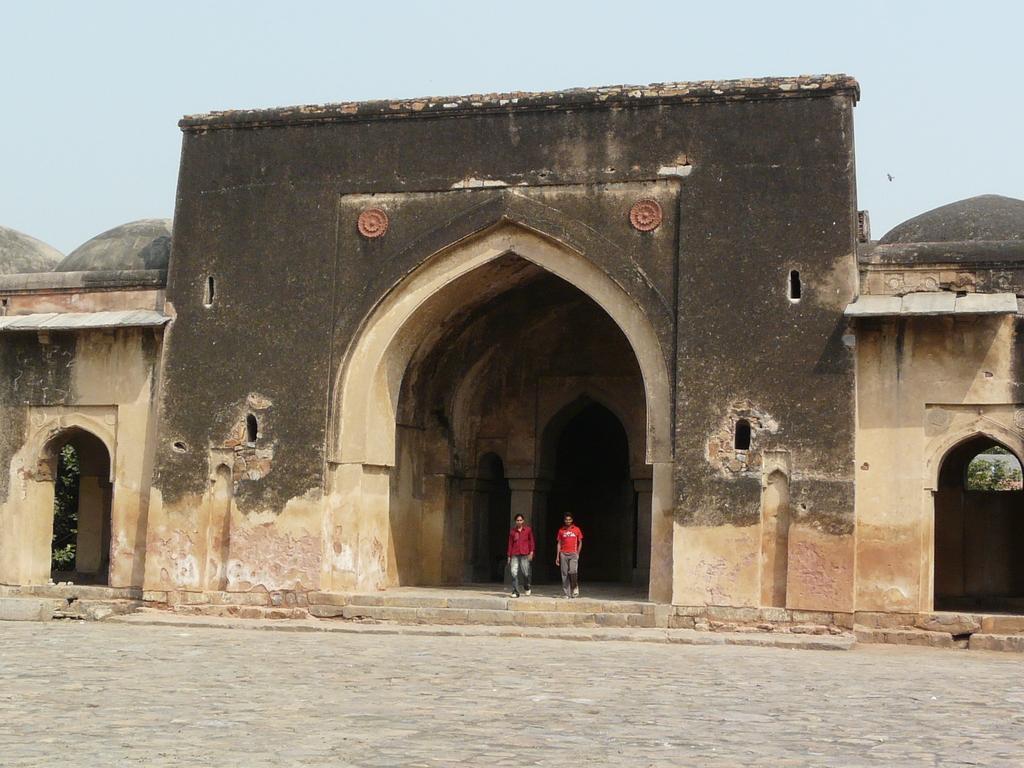Please provide a concise description of this image. In this picture there is a old fort wall with huge arch. In the middle of the photograph we can see two boys wearing red color t-shirt, standing and looking into the camera. In the front bottom side there is a cobbler stones on the ground. 